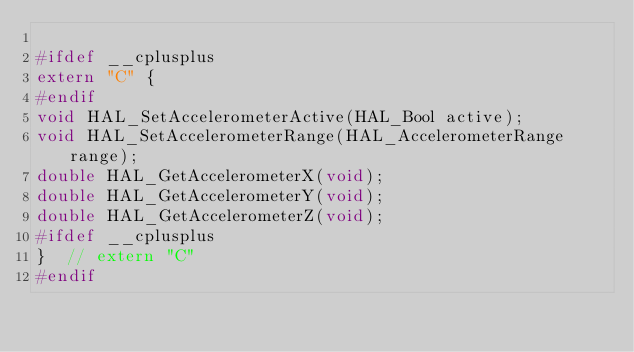<code> <loc_0><loc_0><loc_500><loc_500><_C_>
#ifdef __cplusplus
extern "C" {
#endif
void HAL_SetAccelerometerActive(HAL_Bool active);
void HAL_SetAccelerometerRange(HAL_AccelerometerRange range);
double HAL_GetAccelerometerX(void);
double HAL_GetAccelerometerY(void);
double HAL_GetAccelerometerZ(void);
#ifdef __cplusplus
}  // extern "C"
#endif
</code> 